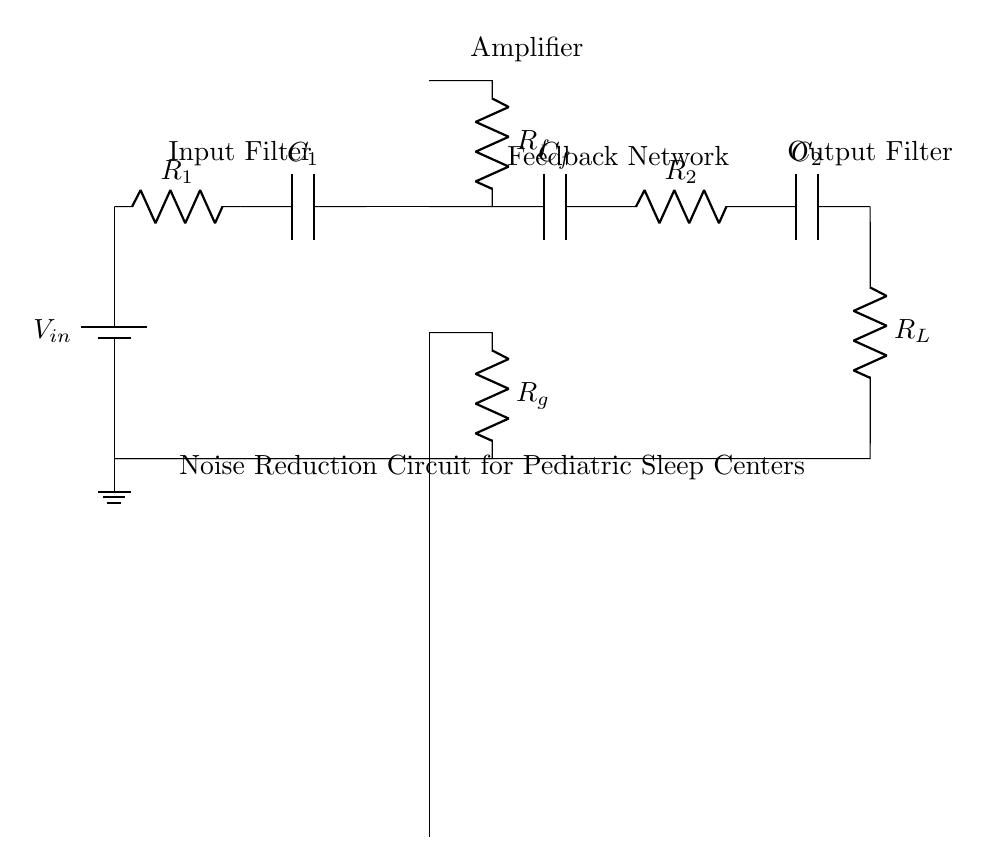What is the input component of the circuit? The input component is a resistor labeled R1, which indicates the initial resistance in the circuit.
Answer: R1 What type of amplifier is used in this circuit? The circuit diagram shows an operational amplifier, which is commonly used for signal amplification tasks in electronic circuits.
Answer: Operational amplifier What components are in the feedback loop? The feedback loop consists of a capacitor labeled Cf and a resistor labeled Rf that connect back to the output of the operational amplifier, allowing for the regulation of signal feedback.
Answer: Cf, Rf What is the purpose of the capacitor C1 in the input stage? Capacitor C1 acts as an input filter, helping to smooth out any fluctuations in the input voltage before it reaches the amplifier stage.
Answer: Input filter How many stages are present in this noise reduction circuit? The noise reduction circuit consists of four stages: input filter, amplifier, feedback network, and output filter.
Answer: Four What is the load resistance in the output stage of the circuit? The load resistance in the output stage is represented by the resistor labeled Rl, which is crucial for determining the output behavior of the circuit.
Answer: Rl What does the ground symbol represent in the circuit? The ground symbol indicates the reference point for the circuit where all voltages are measured against, effectively providing a common return path for the current.
Answer: Reference point 